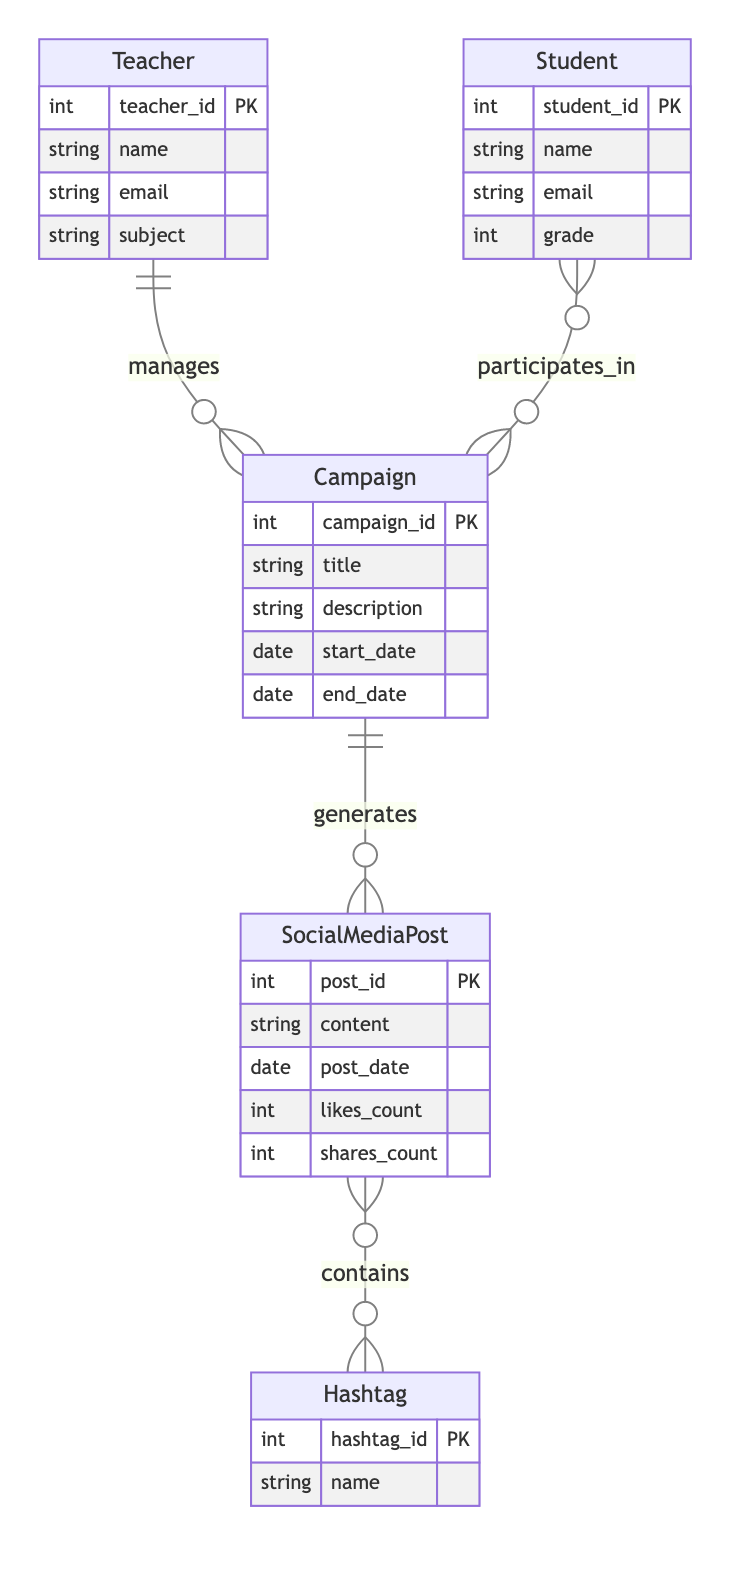What is the primary key of the Student entity? The primary key of the Student entity is defined in the diagram as `student_id`, which uniquely identifies each student.
Answer: student_id How many total entities are present in the diagram? The diagram lists five entities: Teacher, Student, Campaign, SocialMediaPost, and Hashtag. Therefore, the total count is five.
Answer: 5 What is the relationship between Teacher and Campaign? The relationship is labeled as `manages`, which indicates that each Teacher is responsible for managing multiple Campaigns (1:N relationship).
Answer: manages How many Social Media Posts can be associated with one Campaign? According to the diagram, one Campaign can generate multiple Social Media Posts, showing a 1:N relationship, meaning one Campaign can have many posts.
Answer: many What is the cardinality of the relationship between Student and Campaign? The relationship is described as M:N (many-to-many), indicating that multiple Students can participate in multiple Campaigns.
Answer: M:N Which entity shares a N:M relationship with Social Media Post? The entity that shares an N:M relationship with Social Media Post is Hashtag, showing that multiple posts can contain multiple hashtags.
Answer: Hashtag What is the primary key for the Campaign entity? The primary key for the Campaign entity is denoted as `campaign_id`, which uniquely identifies each campaign in the diagram.
Answer: campaign_id Who generates the Social Media Posts according to the diagram? Campaigns are responsible for generating Social Media Posts, indicating a direct relationship where each Campaign can create multiple posts.
Answer: Campaign What kind of information is stored in the Hashtag entity? The Hashtag entity contains information with the attribute `name` which represents the actual hashtag used in posts.
Answer: name 